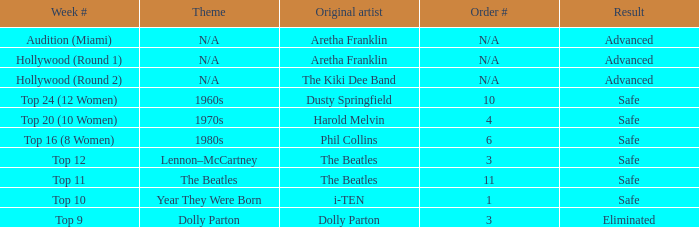What is the week number with phil collins as the initial artist? Top 16 (8 Women). 